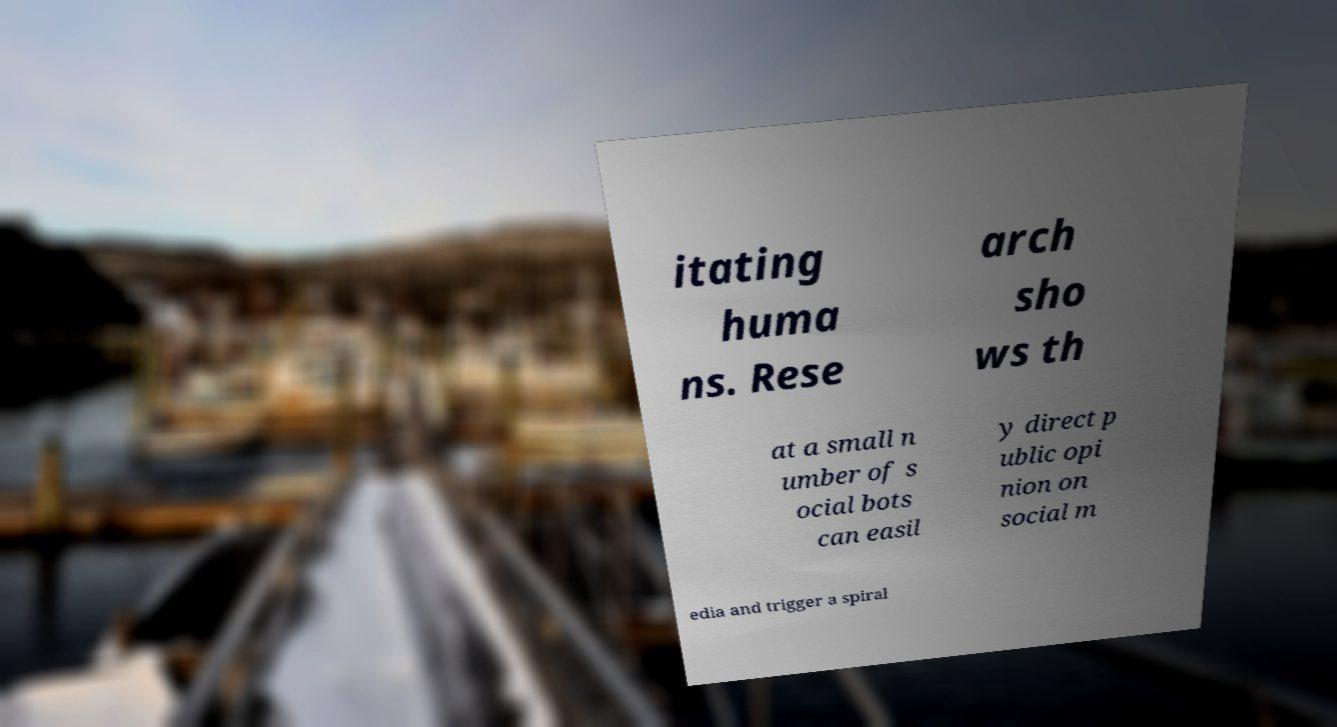Could you extract and type out the text from this image? itating huma ns. Rese arch sho ws th at a small n umber of s ocial bots can easil y direct p ublic opi nion on social m edia and trigger a spiral 